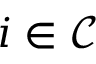Convert formula to latex. <formula><loc_0><loc_0><loc_500><loc_500>i \in \mathcal { C }</formula> 